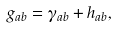Convert formula to latex. <formula><loc_0><loc_0><loc_500><loc_500>g _ { a b } = \gamma _ { a b } + h _ { a b } ,</formula> 